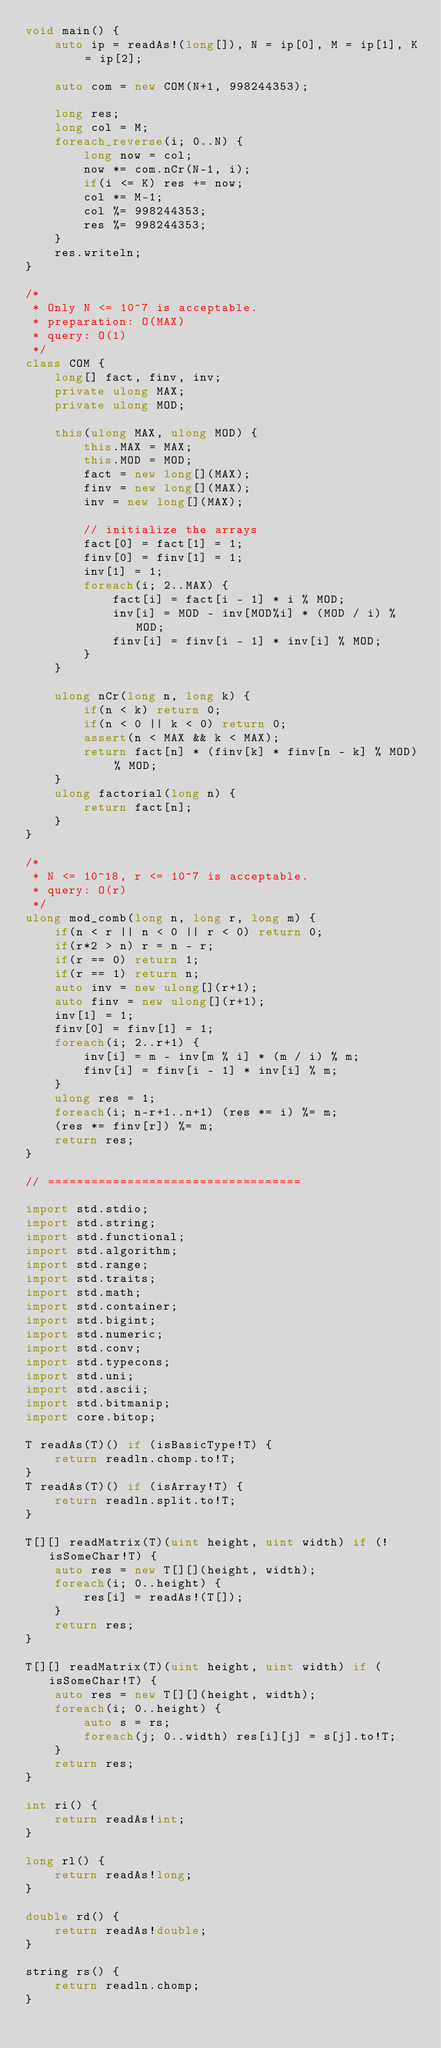<code> <loc_0><loc_0><loc_500><loc_500><_D_>void main() {
	auto ip = readAs!(long[]), N = ip[0], M = ip[1], K = ip[2];

	auto com = new COM(N+1, 998244353);

	long res;
	long col = M;
	foreach_reverse(i; 0..N) {
		long now = col;
		now *= com.nCr(N-1, i);
		if(i <= K) res += now;
		col *= M-1;
		col %= 998244353;
		res %= 998244353;
	}
	res.writeln;
}

/*
 * Only N <= 10^7 is acceptable.
 * preparation: O(MAX)
 * query: O(1)
 */
class COM {
	long[] fact, finv, inv;
	private ulong MAX;
	private ulong MOD;

	this(ulong MAX, ulong MOD) {
		this.MAX = MAX;
		this.MOD = MOD;
		fact = new long[](MAX);
		finv = new long[](MAX);
		inv = new long[](MAX);

		// initialize the arrays
		fact[0] = fact[1] = 1;
		finv[0] = finv[1] = 1;
		inv[1] = 1;
		foreach(i; 2..MAX) {
			fact[i] = fact[i - 1] * i % MOD;
			inv[i] = MOD - inv[MOD%i] * (MOD / i) % MOD;
			finv[i] = finv[i - 1] * inv[i] % MOD;
		}
	}

	ulong nCr(long n, long k) {
		if(n < k) return 0;
		if(n < 0 || k < 0) return 0;
		assert(n < MAX && k < MAX);
		return fact[n] * (finv[k] * finv[n - k] % MOD) % MOD;
	}
	ulong factorial(long n) {
		return fact[n];
	}
}

/*
 * N <= 10^18, r <= 10^7 is acceptable.
 * query: O(r)
 */
ulong mod_comb(long n, long r, long m) {
	if(n < r || n < 0 || r < 0) return 0;
	if(r*2 > n) r = n - r;
	if(r == 0) return 1;
	if(r == 1) return n;
	auto inv = new ulong[](r+1);
	auto finv = new ulong[](r+1);
	inv[1] = 1;
	finv[0] = finv[1] = 1;
	foreach(i; 2..r+1) {
		inv[i] = m - inv[m % i] * (m / i) % m;
		finv[i] = finv[i - 1] * inv[i] % m;
	}
	ulong res = 1;
	foreach(i; n-r+1..n+1) (res *= i) %= m;
	(res *= finv[r]) %= m;
	return res;
}

// ===================================

import std.stdio;
import std.string;
import std.functional;
import std.algorithm;
import std.range;
import std.traits;
import std.math;
import std.container;
import std.bigint;
import std.numeric;
import std.conv;
import std.typecons;
import std.uni;
import std.ascii;
import std.bitmanip;
import core.bitop;

T readAs(T)() if (isBasicType!T) {
	return readln.chomp.to!T;
}
T readAs(T)() if (isArray!T) {
	return readln.split.to!T;
}

T[][] readMatrix(T)(uint height, uint width) if (!isSomeChar!T) {
	auto res = new T[][](height, width);
	foreach(i; 0..height) {
		res[i] = readAs!(T[]);
	}
	return res;
}

T[][] readMatrix(T)(uint height, uint width) if (isSomeChar!T) {
	auto res = new T[][](height, width);
	foreach(i; 0..height) {
		auto s = rs;
		foreach(j; 0..width) res[i][j] = s[j].to!T;
	}
	return res;
}

int ri() {
	return readAs!int;
}

long rl() {
	return readAs!long;
}

double rd() {
	return readAs!double;
}

string rs() {
	return readln.chomp;
}</code> 